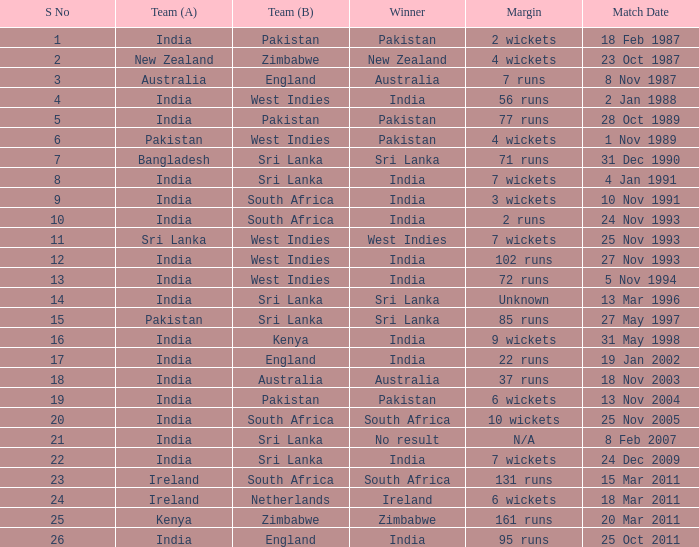What was the margin of the match on 19 Jan 2002? 22 runs. 